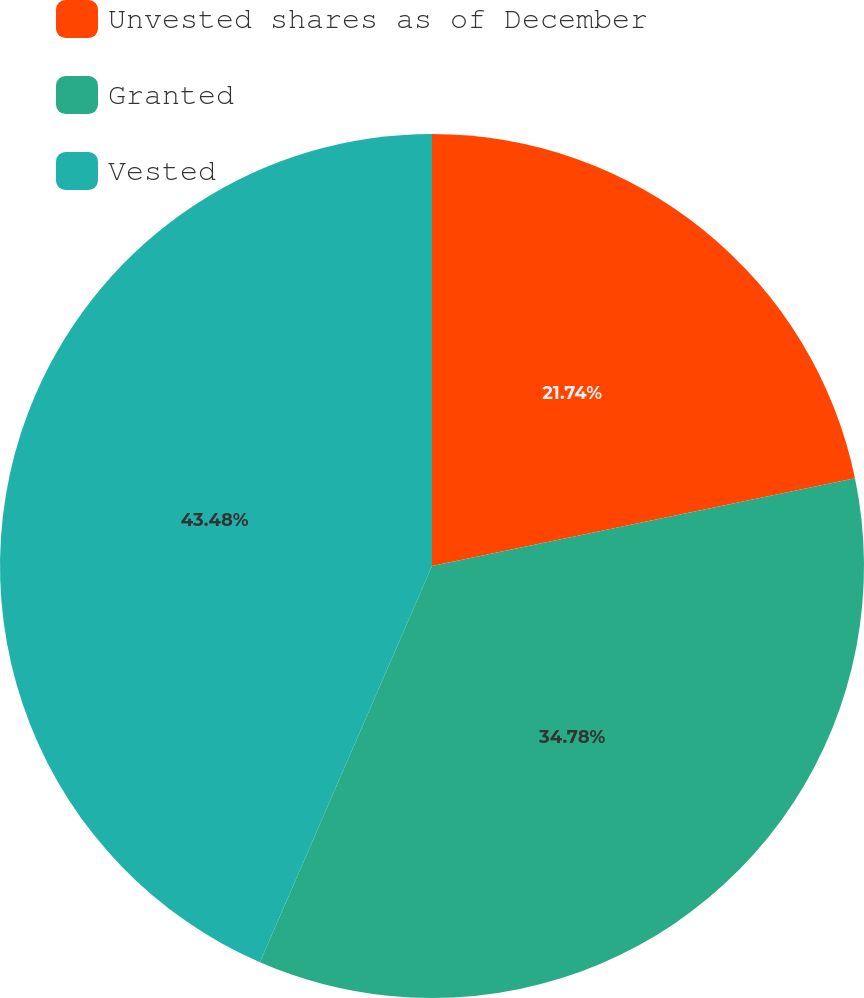<chart> <loc_0><loc_0><loc_500><loc_500><pie_chart><fcel>Unvested shares as of December<fcel>Granted<fcel>Vested<nl><fcel>21.74%<fcel>34.78%<fcel>43.48%<nl></chart> 